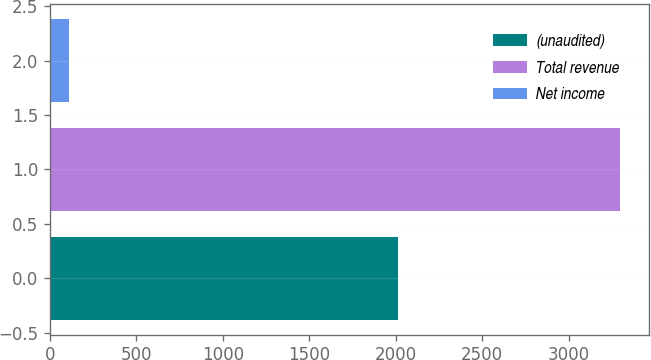Convert chart to OTSL. <chart><loc_0><loc_0><loc_500><loc_500><bar_chart><fcel>(unaudited)<fcel>Total revenue<fcel>Net income<nl><fcel>2015<fcel>3297.7<fcel>107.6<nl></chart> 